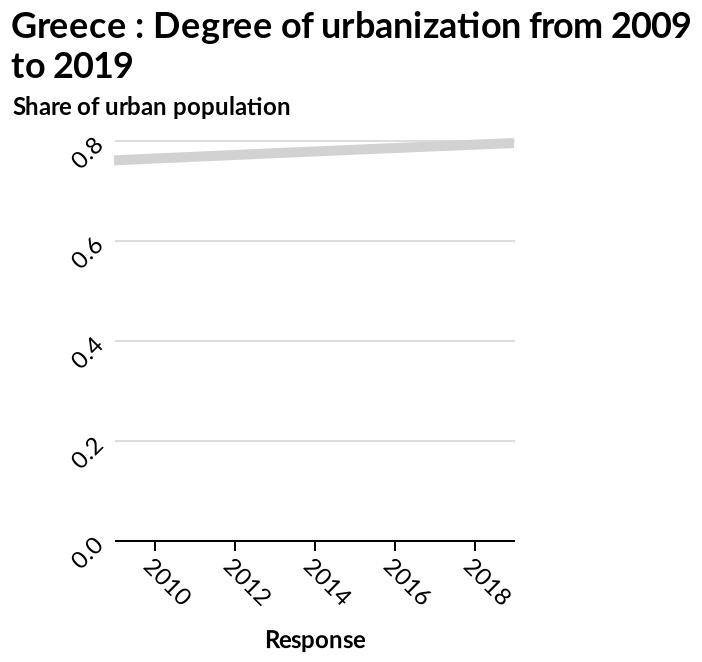<image>
What type of scale is used for the y-axis? A linear scale is used for the y-axis, ranging from 0.0 to 0.8. What is the range of values on the y-axis of the line chart? The range of values on the y-axis is from 0.0 to 0.8, representing the share of urban population. Describe the following image in detail Greece : Degree of urbanization from 2009 to 2019 is a line chart. There is a linear scale with a minimum of 0.0 and a maximum of 0.8 along the y-axis, marked Share of urban population. A linear scale with a minimum of 2010 and a maximum of 2018 can be seen on the x-axis, labeled Response. 